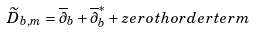Convert formula to latex. <formula><loc_0><loc_0><loc_500><loc_500>\widetilde { D } _ { b , m } = \overline { \partial } _ { b } + \overline { \partial } ^ { * } _ { b } + z e r o t h o r d e r t e r m</formula> 